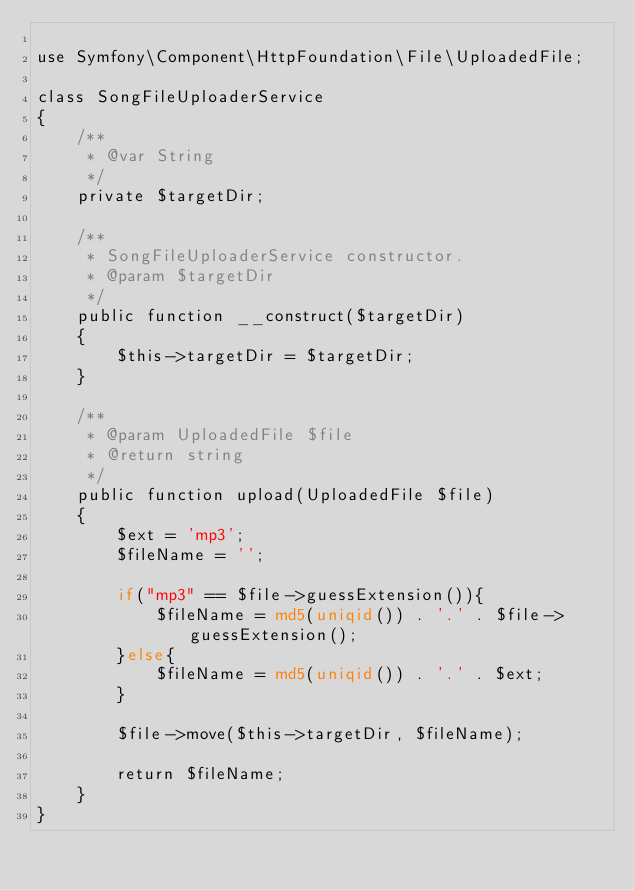Convert code to text. <code><loc_0><loc_0><loc_500><loc_500><_PHP_>
use Symfony\Component\HttpFoundation\File\UploadedFile;

class SongFileUploaderService
{
    /**
     * @var String
     */
    private $targetDir;

    /**
     * SongFileUploaderService constructor.
     * @param $targetDir
     */
    public function __construct($targetDir)
    {
        $this->targetDir = $targetDir;
    }

    /**
     * @param UploadedFile $file
     * @return string
     */
    public function upload(UploadedFile $file)
    {
        $ext = 'mp3';
        $fileName = '';

        if("mp3" == $file->guessExtension()){
            $fileName = md5(uniqid()) . '.' . $file->guessExtension();
        }else{
            $fileName = md5(uniqid()) . '.' . $ext;
        }

        $file->move($this->targetDir, $fileName);

        return $fileName;
    }
}</code> 